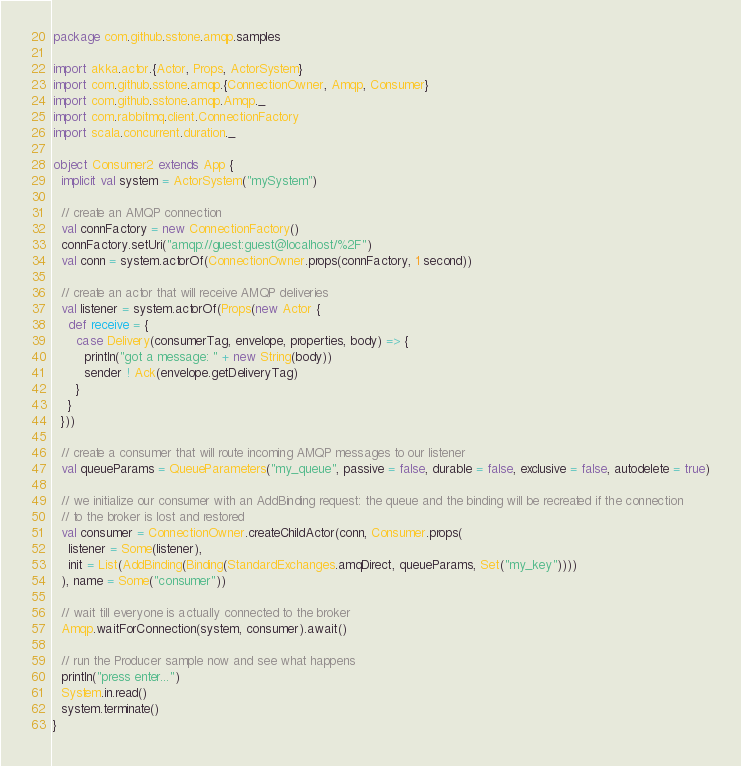<code> <loc_0><loc_0><loc_500><loc_500><_Scala_>package com.github.sstone.amqp.samples

import akka.actor.{Actor, Props, ActorSystem}
import com.github.sstone.amqp.{ConnectionOwner, Amqp, Consumer}
import com.github.sstone.amqp.Amqp._
import com.rabbitmq.client.ConnectionFactory
import scala.concurrent.duration._

object Consumer2 extends App {
  implicit val system = ActorSystem("mySystem")

  // create an AMQP connection
  val connFactory = new ConnectionFactory()
  connFactory.setUri("amqp://guest:guest@localhost/%2F")
  val conn = system.actorOf(ConnectionOwner.props(connFactory, 1 second))

  // create an actor that will receive AMQP deliveries
  val listener = system.actorOf(Props(new Actor {
    def receive = {
      case Delivery(consumerTag, envelope, properties, body) => {
        println("got a message: " + new String(body))
        sender ! Ack(envelope.getDeliveryTag)
      }
    }
  }))

  // create a consumer that will route incoming AMQP messages to our listener
  val queueParams = QueueParameters("my_queue", passive = false, durable = false, exclusive = false, autodelete = true)

  // we initialize our consumer with an AddBinding request: the queue and the binding will be recreated if the connection
  // to the broker is lost and restored
  val consumer = ConnectionOwner.createChildActor(conn, Consumer.props(
    listener = Some(listener),
    init = List(AddBinding(Binding(StandardExchanges.amqDirect, queueParams, Set("my_key"))))
  ), name = Some("consumer"))

  // wait till everyone is actually connected to the broker
  Amqp.waitForConnection(system, consumer).await()

  // run the Producer sample now and see what happens
  println("press enter...")
  System.in.read()
  system.terminate()
}
</code> 